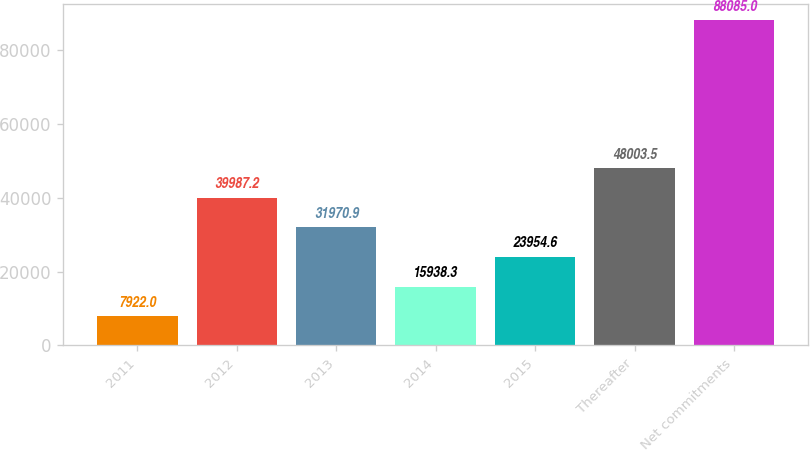Convert chart. <chart><loc_0><loc_0><loc_500><loc_500><bar_chart><fcel>2011<fcel>2012<fcel>2013<fcel>2014<fcel>2015<fcel>Thereafter<fcel>Net commitments<nl><fcel>7922<fcel>39987.2<fcel>31970.9<fcel>15938.3<fcel>23954.6<fcel>48003.5<fcel>88085<nl></chart> 